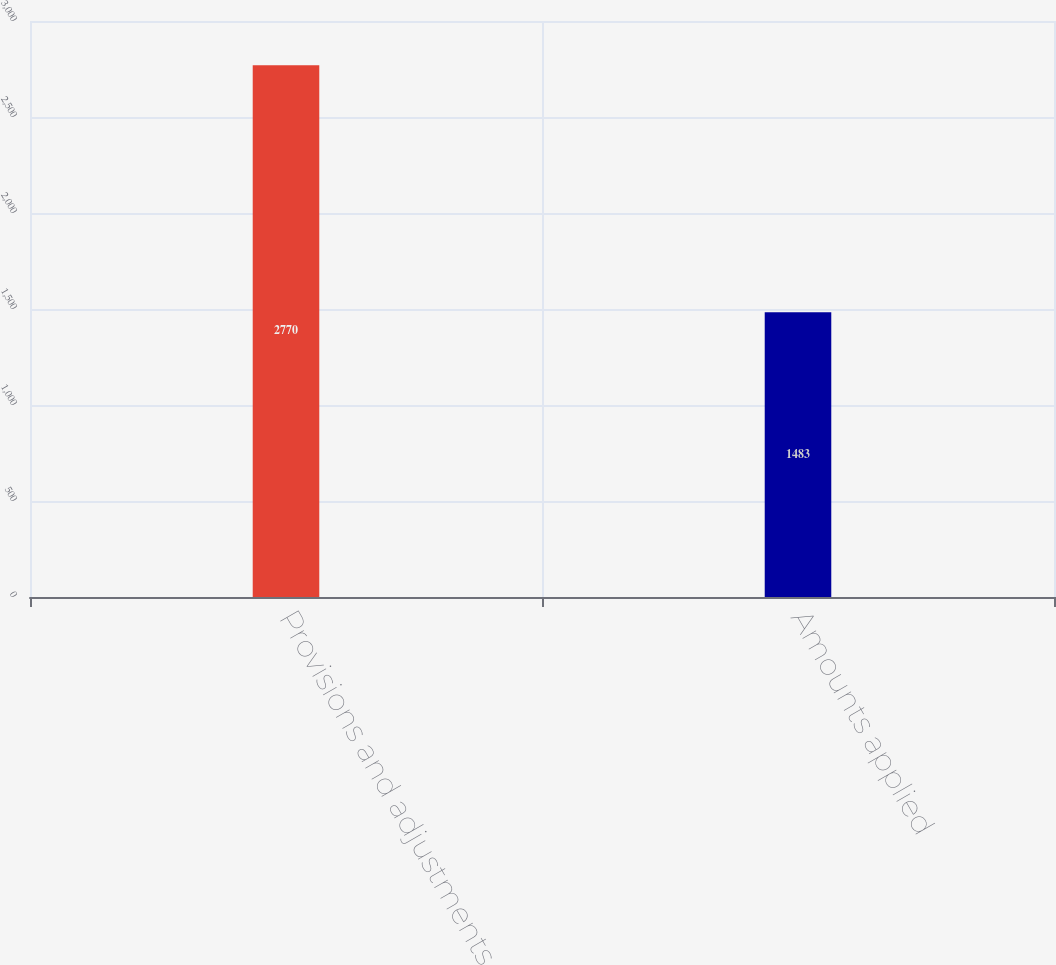Convert chart to OTSL. <chart><loc_0><loc_0><loc_500><loc_500><bar_chart><fcel>Provisions and adjustments<fcel>Amounts applied<nl><fcel>2770<fcel>1483<nl></chart> 